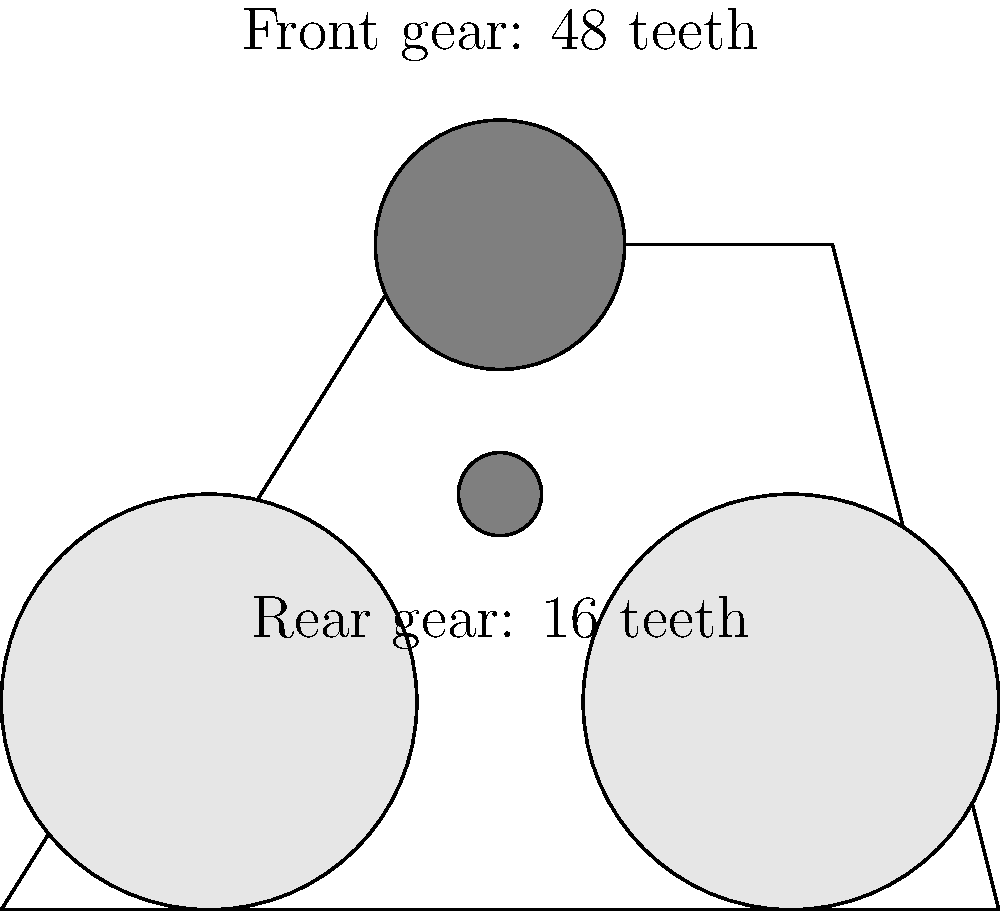A bicycle has a front gear with 48 teeth and a rear gear with 16 teeth. What is the gear ratio of this transmission system? Express your answer as a decimal rounded to two places. To calculate the gear ratio in a bicycle transmission system, we follow these steps:

1. Identify the number of teeth on the front gear (driver gear):
   Front gear teeth = 48

2. Identify the number of teeth on the rear gear (driven gear):
   Rear gear teeth = 16

3. Calculate the gear ratio using the formula:
   Gear ratio = (Number of teeth on front gear) / (Number of teeth on rear gear)

4. Substitute the values:
   Gear ratio = 48 / 16

5. Perform the division:
   Gear ratio = 3

6. Round to two decimal places:
   Gear ratio ≈ 3.00

The gear ratio of 3.00 means that for every complete revolution of the pedals (front gear), the rear wheel will rotate 3 times. This relatively high gear ratio indicates a setup for speed rather than climbing, which aligns with the persona of an unenthused Belgian tennis fan who doesn't enjoy close matches and likely prefers quick, decisive outcomes.
Answer: 3.00 